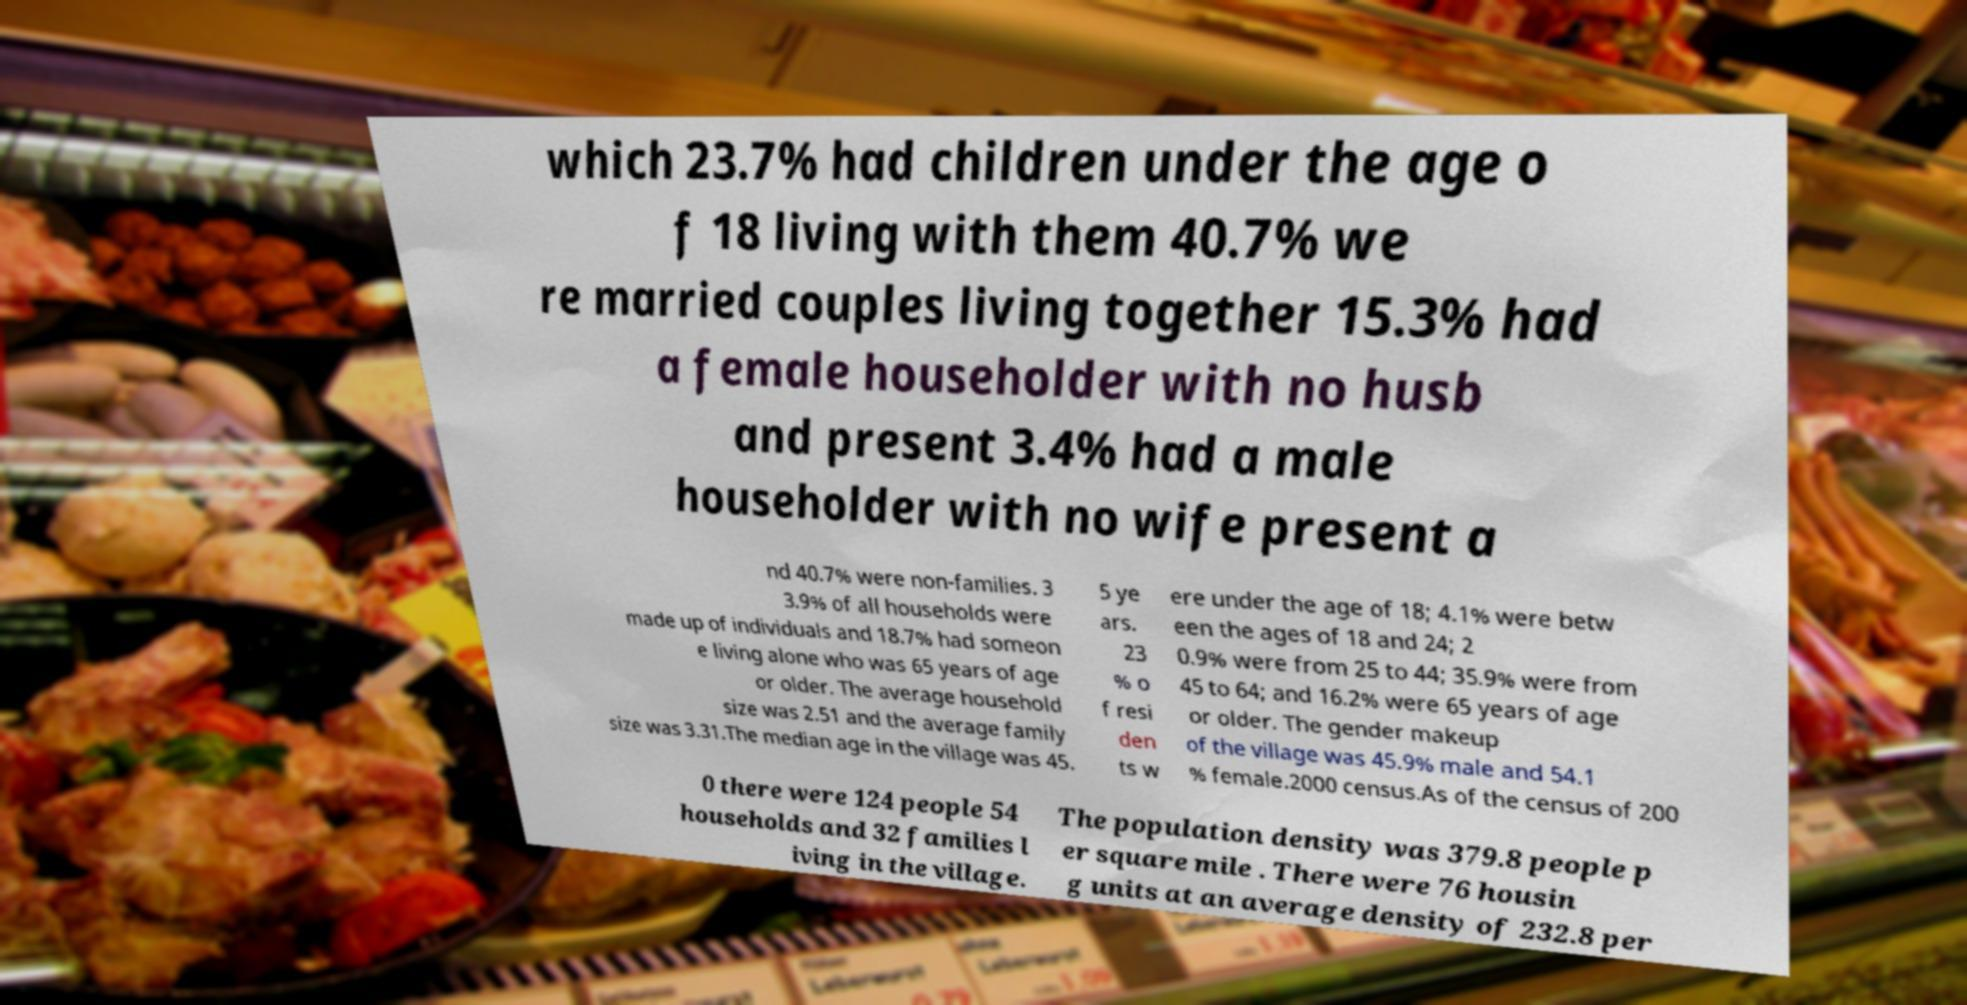Could you extract and type out the text from this image? which 23.7% had children under the age o f 18 living with them 40.7% we re married couples living together 15.3% had a female householder with no husb and present 3.4% had a male householder with no wife present a nd 40.7% were non-families. 3 3.9% of all households were made up of individuals and 18.7% had someon e living alone who was 65 years of age or older. The average household size was 2.51 and the average family size was 3.31.The median age in the village was 45. 5 ye ars. 23 % o f resi den ts w ere under the age of 18; 4.1% were betw een the ages of 18 and 24; 2 0.9% were from 25 to 44; 35.9% were from 45 to 64; and 16.2% were 65 years of age or older. The gender makeup of the village was 45.9% male and 54.1 % female.2000 census.As of the census of 200 0 there were 124 people 54 households and 32 families l iving in the village. The population density was 379.8 people p er square mile . There were 76 housin g units at an average density of 232.8 per 